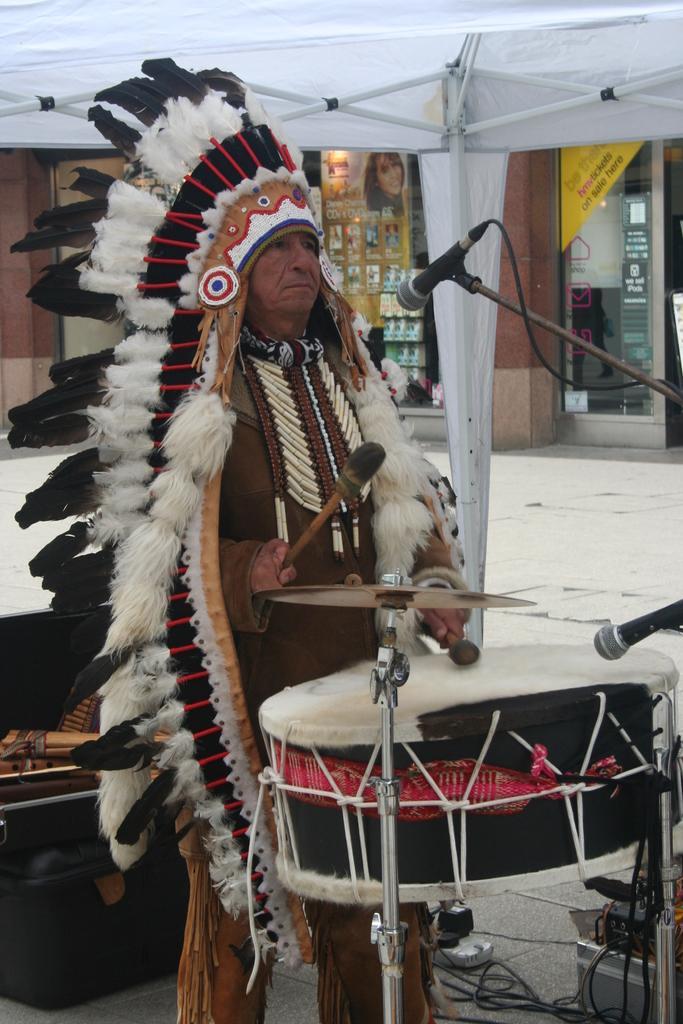Could you give a brief overview of what you see in this image? In this image there is a person standing and playing drums under the tent. At the back there is a building, at the bottom there is a box and a wire. 